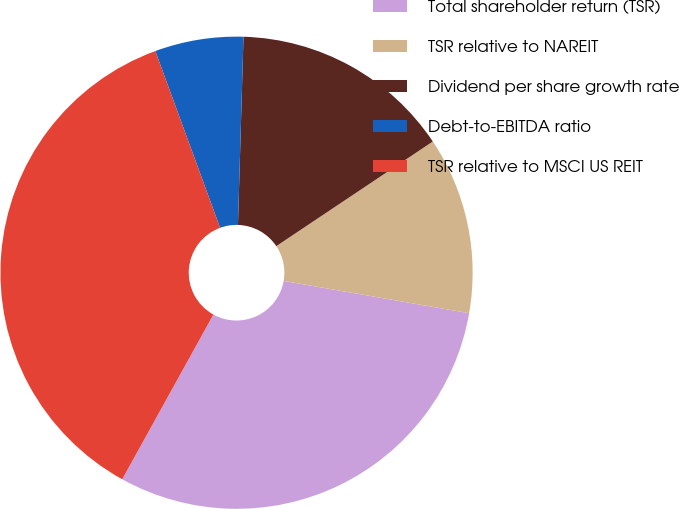Convert chart to OTSL. <chart><loc_0><loc_0><loc_500><loc_500><pie_chart><fcel>Total shareholder return (TSR)<fcel>TSR relative to NAREIT<fcel>Dividend per share growth rate<fcel>Debt-to-EBITDA ratio<fcel>TSR relative to MSCI US REIT<nl><fcel>30.3%<fcel>12.12%<fcel>15.15%<fcel>6.06%<fcel>36.36%<nl></chart> 